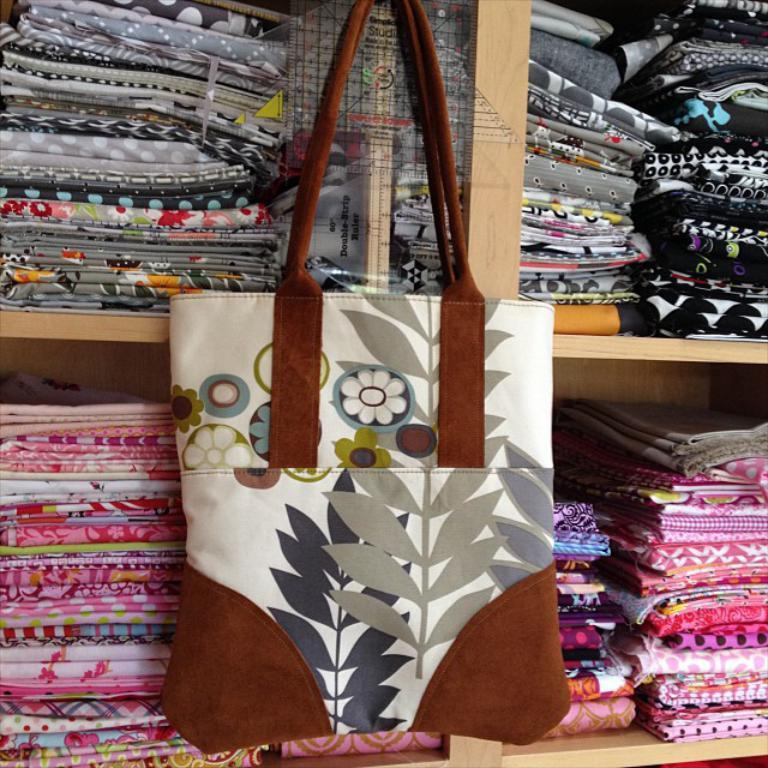What can be seen hanging from one of the racks in the image? There is a handbag hanging from one of the racks. What else is present on the racks in the image? The racks in the image have clothes on them. Can you see any trails or falls in the image? There are no trails or falls visible in the image. Is there a drain present in the image? There is no drain present in the image. 